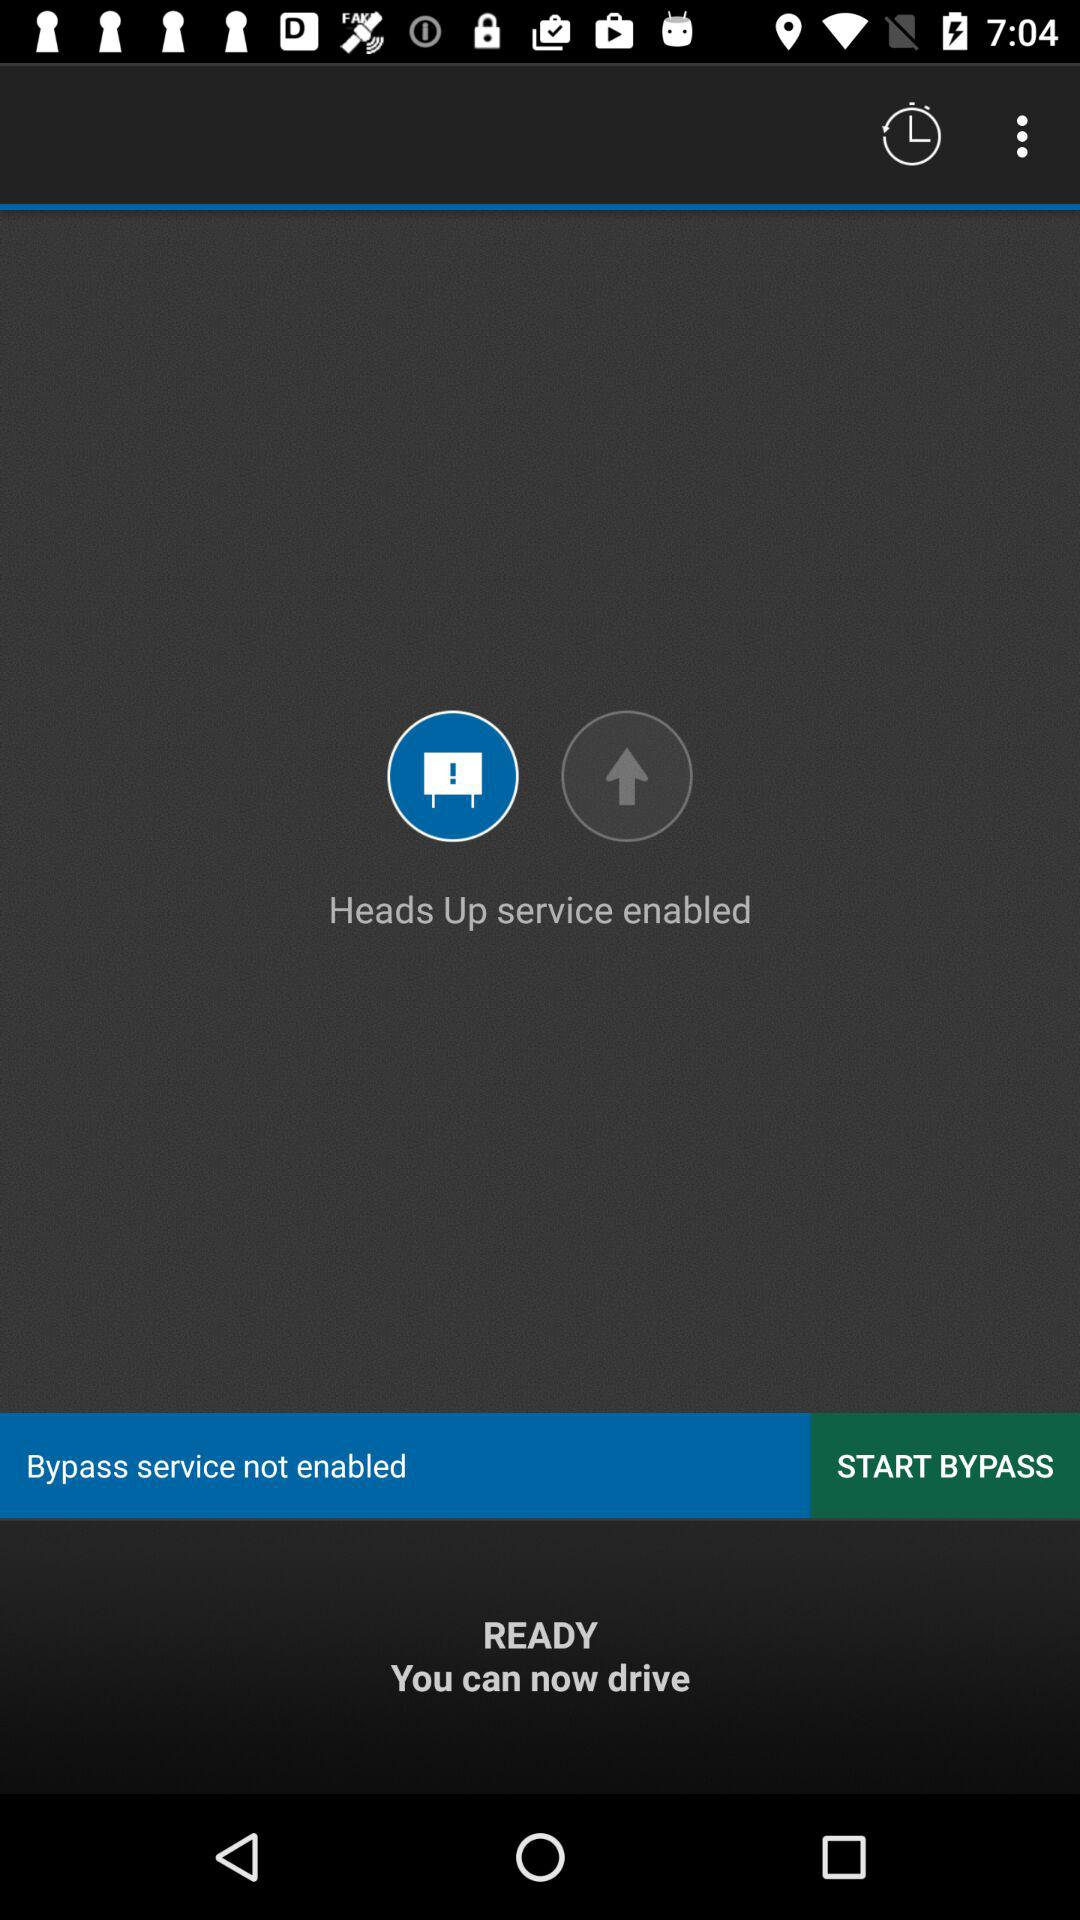Is "Heads Up service" enabled or disabled? "Heads Up service" is enabled. 